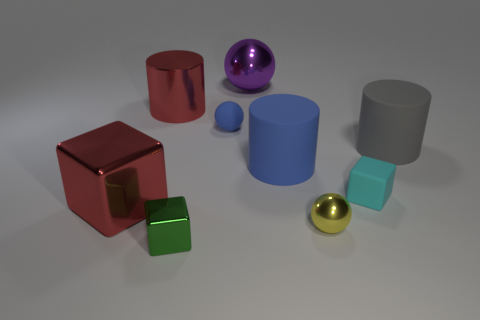What number of objects are things that are behind the green shiny object or big red metallic things in front of the small cyan block?
Make the answer very short. 8. Are there any other things that are the same color as the small metallic sphere?
Provide a short and direct response. No. There is a shiny ball that is behind the cylinder that is on the left side of the ball behind the big red metal cylinder; what is its color?
Give a very brief answer. Purple. There is a rubber cylinder right of the yellow shiny sphere that is to the right of the red shiny block; what size is it?
Offer a very short reply. Large. There is a large thing that is in front of the blue matte ball and on the left side of the blue matte ball; what is its material?
Make the answer very short. Metal. There is a rubber sphere; is its size the same as the blue matte thing that is on the right side of the small blue rubber ball?
Your response must be concise. No. Are any large gray rubber cylinders visible?
Make the answer very short. Yes. There is another large thing that is the same shape as the green shiny object; what is its material?
Offer a terse response. Metal. What is the size of the red thing to the right of the cube left of the small cube on the left side of the blue sphere?
Give a very brief answer. Large. Are there any gray things on the left side of the tiny rubber cube?
Give a very brief answer. No. 